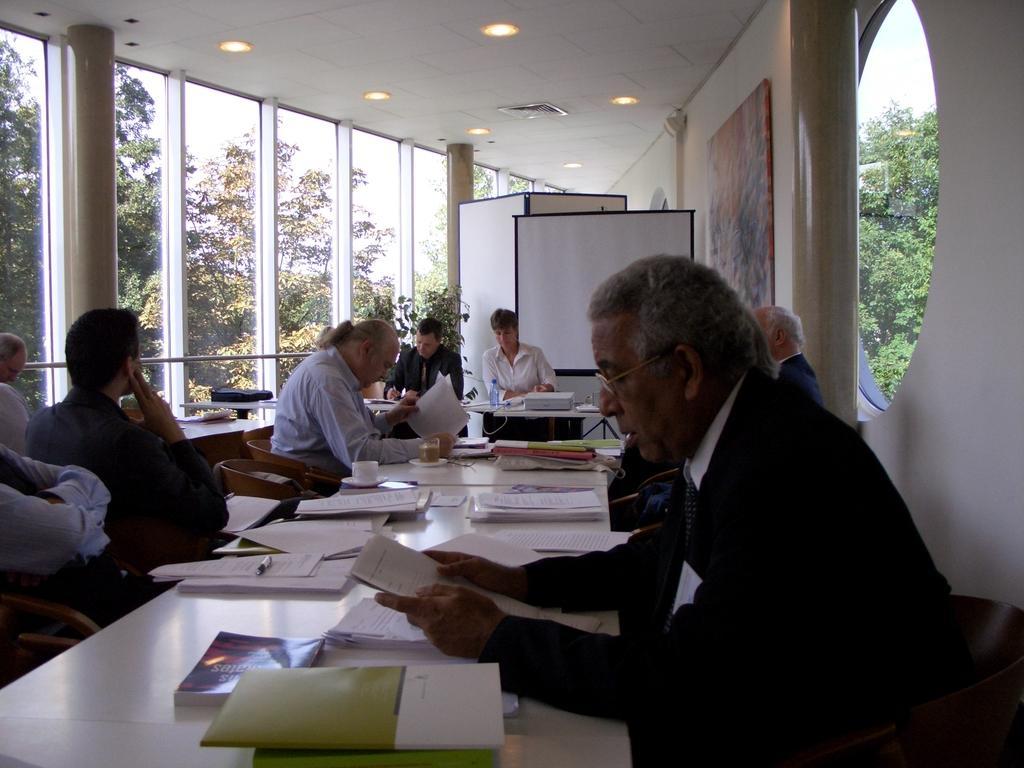Please provide a concise description of this image. Some people are sitting in chairs at tables with some papers in their hand. 